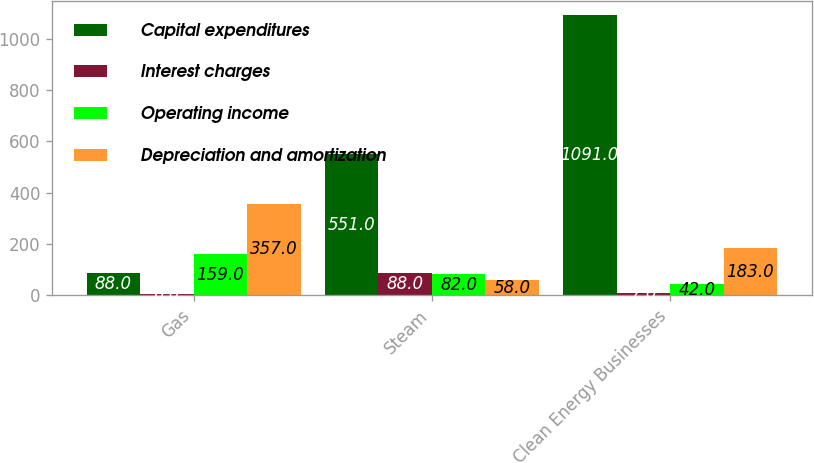<chart> <loc_0><loc_0><loc_500><loc_500><stacked_bar_chart><ecel><fcel>Gas<fcel>Steam<fcel>Clean Energy Businesses<nl><fcel>Capital expenditures<fcel>88<fcel>551<fcel>1091<nl><fcel>Interest charges<fcel>6<fcel>88<fcel>7<nl><fcel>Operating income<fcel>159<fcel>82<fcel>42<nl><fcel>Depreciation and amortization<fcel>357<fcel>58<fcel>183<nl></chart> 